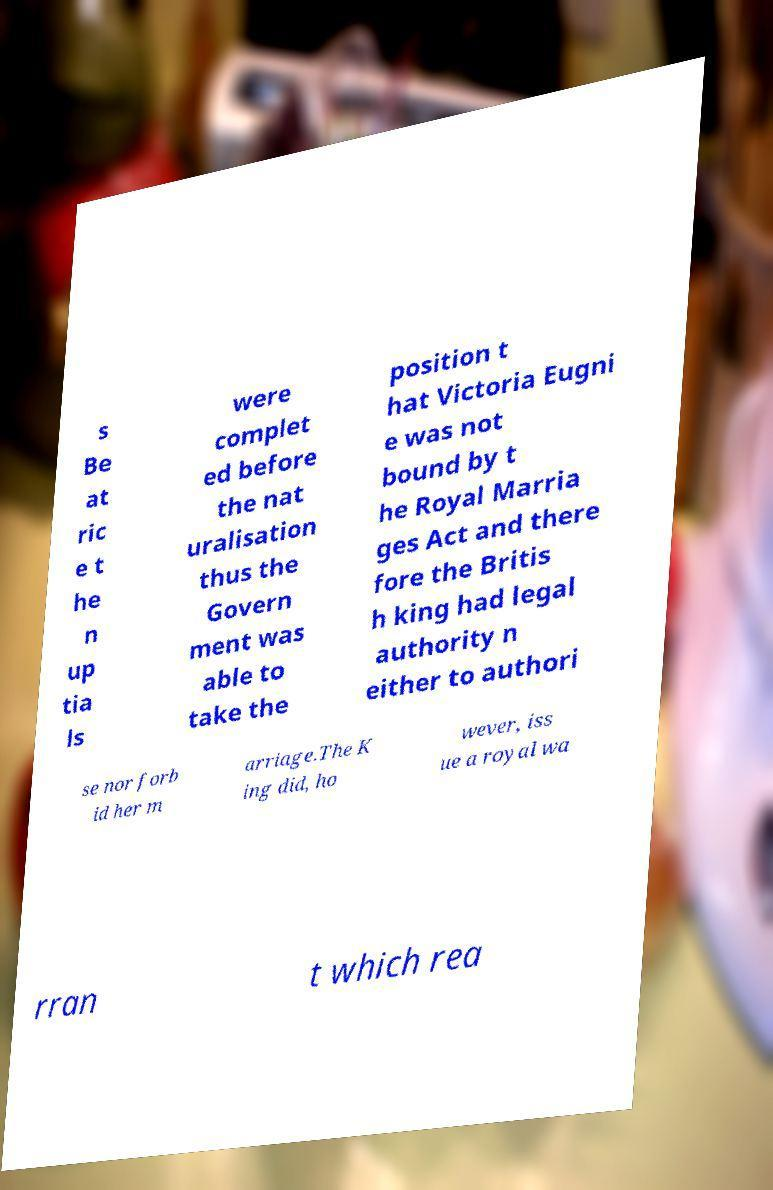Can you read and provide the text displayed in the image?This photo seems to have some interesting text. Can you extract and type it out for me? s Be at ric e t he n up tia ls were complet ed before the nat uralisation thus the Govern ment was able to take the position t hat Victoria Eugni e was not bound by t he Royal Marria ges Act and there fore the Britis h king had legal authority n either to authori se nor forb id her m arriage.The K ing did, ho wever, iss ue a royal wa rran t which rea 